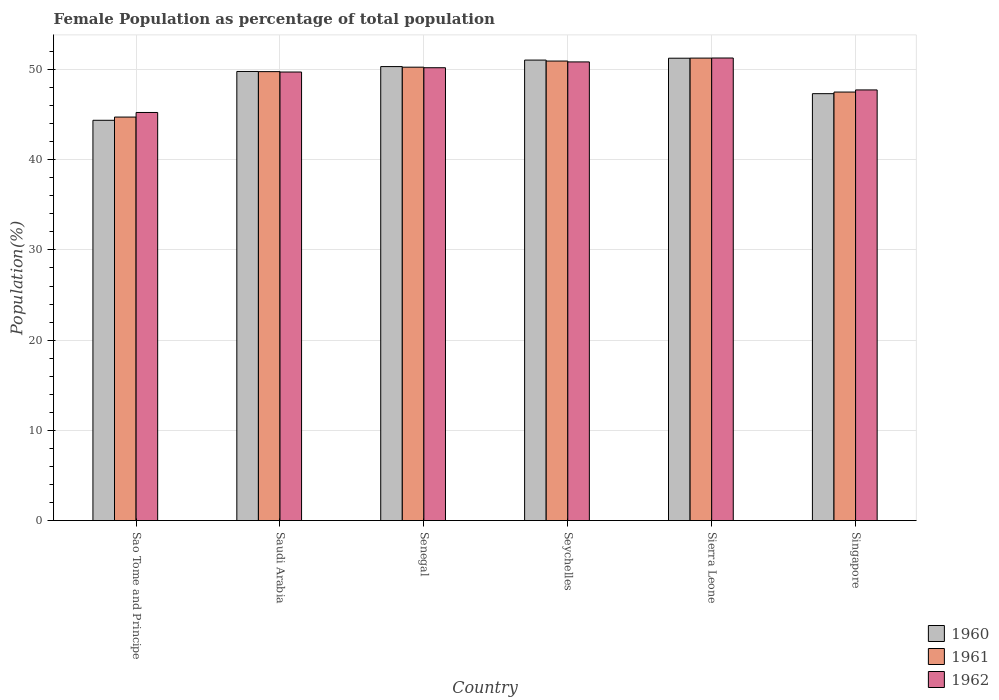How many bars are there on the 5th tick from the left?
Your answer should be compact. 3. What is the label of the 3rd group of bars from the left?
Give a very brief answer. Senegal. In how many cases, is the number of bars for a given country not equal to the number of legend labels?
Ensure brevity in your answer.  0. What is the female population in in 1960 in Saudi Arabia?
Ensure brevity in your answer.  49.78. Across all countries, what is the maximum female population in in 1962?
Provide a short and direct response. 51.27. Across all countries, what is the minimum female population in in 1960?
Your response must be concise. 44.37. In which country was the female population in in 1961 maximum?
Give a very brief answer. Sierra Leone. In which country was the female population in in 1961 minimum?
Your answer should be compact. Sao Tome and Principe. What is the total female population in in 1960 in the graph?
Your response must be concise. 294.09. What is the difference between the female population in in 1960 in Senegal and that in Sierra Leone?
Offer a very short reply. -0.93. What is the difference between the female population in in 1962 in Sao Tome and Principe and the female population in in 1960 in Seychelles?
Keep it short and to the point. -5.81. What is the average female population in in 1962 per country?
Provide a succinct answer. 49.17. What is the difference between the female population in of/in 1960 and female population in of/in 1962 in Sao Tome and Principe?
Your answer should be compact. -0.87. In how many countries, is the female population in in 1962 greater than 20 %?
Ensure brevity in your answer.  6. What is the ratio of the female population in in 1961 in Sao Tome and Principe to that in Sierra Leone?
Your answer should be compact. 0.87. Is the difference between the female population in in 1960 in Sao Tome and Principe and Sierra Leone greater than the difference between the female population in in 1962 in Sao Tome and Principe and Sierra Leone?
Ensure brevity in your answer.  No. What is the difference between the highest and the second highest female population in in 1962?
Your answer should be compact. -0.43. What is the difference between the highest and the lowest female population in in 1961?
Your answer should be compact. 6.54. What does the 3rd bar from the right in Senegal represents?
Offer a terse response. 1960. Is it the case that in every country, the sum of the female population in in 1961 and female population in in 1960 is greater than the female population in in 1962?
Provide a short and direct response. Yes. Are all the bars in the graph horizontal?
Ensure brevity in your answer.  No. Does the graph contain any zero values?
Give a very brief answer. No. Does the graph contain grids?
Ensure brevity in your answer.  Yes. How many legend labels are there?
Give a very brief answer. 3. How are the legend labels stacked?
Offer a very short reply. Vertical. What is the title of the graph?
Provide a succinct answer. Female Population as percentage of total population. What is the label or title of the Y-axis?
Ensure brevity in your answer.  Population(%). What is the Population(%) of 1960 in Sao Tome and Principe?
Make the answer very short. 44.37. What is the Population(%) in 1961 in Sao Tome and Principe?
Your response must be concise. 44.73. What is the Population(%) of 1962 in Sao Tome and Principe?
Your answer should be very brief. 45.24. What is the Population(%) of 1960 in Saudi Arabia?
Ensure brevity in your answer.  49.78. What is the Population(%) in 1961 in Saudi Arabia?
Provide a short and direct response. 49.76. What is the Population(%) of 1962 in Saudi Arabia?
Your answer should be very brief. 49.72. What is the Population(%) of 1960 in Senegal?
Ensure brevity in your answer.  50.32. What is the Population(%) of 1961 in Senegal?
Make the answer very short. 50.26. What is the Population(%) of 1962 in Senegal?
Your answer should be compact. 50.2. What is the Population(%) in 1960 in Seychelles?
Offer a terse response. 51.04. What is the Population(%) in 1961 in Seychelles?
Keep it short and to the point. 50.94. What is the Population(%) of 1962 in Seychelles?
Offer a terse response. 50.84. What is the Population(%) of 1960 in Sierra Leone?
Give a very brief answer. 51.25. What is the Population(%) of 1961 in Sierra Leone?
Provide a succinct answer. 51.26. What is the Population(%) in 1962 in Sierra Leone?
Make the answer very short. 51.27. What is the Population(%) in 1960 in Singapore?
Offer a very short reply. 47.32. What is the Population(%) in 1961 in Singapore?
Ensure brevity in your answer.  47.5. What is the Population(%) of 1962 in Singapore?
Provide a succinct answer. 47.74. Across all countries, what is the maximum Population(%) of 1960?
Provide a succinct answer. 51.25. Across all countries, what is the maximum Population(%) of 1961?
Provide a short and direct response. 51.26. Across all countries, what is the maximum Population(%) of 1962?
Offer a terse response. 51.27. Across all countries, what is the minimum Population(%) of 1960?
Provide a succinct answer. 44.37. Across all countries, what is the minimum Population(%) of 1961?
Keep it short and to the point. 44.73. Across all countries, what is the minimum Population(%) in 1962?
Keep it short and to the point. 45.24. What is the total Population(%) of 1960 in the graph?
Offer a very short reply. 294.09. What is the total Population(%) of 1961 in the graph?
Keep it short and to the point. 294.44. What is the total Population(%) of 1962 in the graph?
Make the answer very short. 295. What is the difference between the Population(%) of 1960 in Sao Tome and Principe and that in Saudi Arabia?
Provide a succinct answer. -5.41. What is the difference between the Population(%) in 1961 in Sao Tome and Principe and that in Saudi Arabia?
Your answer should be very brief. -5.04. What is the difference between the Population(%) in 1962 in Sao Tome and Principe and that in Saudi Arabia?
Your answer should be very brief. -4.48. What is the difference between the Population(%) of 1960 in Sao Tome and Principe and that in Senegal?
Ensure brevity in your answer.  -5.95. What is the difference between the Population(%) in 1961 in Sao Tome and Principe and that in Senegal?
Give a very brief answer. -5.53. What is the difference between the Population(%) in 1962 in Sao Tome and Principe and that in Senegal?
Provide a succinct answer. -4.96. What is the difference between the Population(%) of 1960 in Sao Tome and Principe and that in Seychelles?
Provide a short and direct response. -6.67. What is the difference between the Population(%) in 1961 in Sao Tome and Principe and that in Seychelles?
Ensure brevity in your answer.  -6.21. What is the difference between the Population(%) of 1962 in Sao Tome and Principe and that in Seychelles?
Make the answer very short. -5.6. What is the difference between the Population(%) in 1960 in Sao Tome and Principe and that in Sierra Leone?
Your answer should be compact. -6.88. What is the difference between the Population(%) of 1961 in Sao Tome and Principe and that in Sierra Leone?
Ensure brevity in your answer.  -6.54. What is the difference between the Population(%) in 1962 in Sao Tome and Principe and that in Sierra Leone?
Your answer should be very brief. -6.04. What is the difference between the Population(%) of 1960 in Sao Tome and Principe and that in Singapore?
Offer a terse response. -2.95. What is the difference between the Population(%) in 1961 in Sao Tome and Principe and that in Singapore?
Keep it short and to the point. -2.77. What is the difference between the Population(%) of 1962 in Sao Tome and Principe and that in Singapore?
Your response must be concise. -2.5. What is the difference between the Population(%) of 1960 in Saudi Arabia and that in Senegal?
Ensure brevity in your answer.  -0.54. What is the difference between the Population(%) in 1961 in Saudi Arabia and that in Senegal?
Provide a succinct answer. -0.49. What is the difference between the Population(%) of 1962 in Saudi Arabia and that in Senegal?
Offer a very short reply. -0.48. What is the difference between the Population(%) in 1960 in Saudi Arabia and that in Seychelles?
Provide a short and direct response. -1.26. What is the difference between the Population(%) in 1961 in Saudi Arabia and that in Seychelles?
Offer a terse response. -1.17. What is the difference between the Population(%) of 1962 in Saudi Arabia and that in Seychelles?
Give a very brief answer. -1.12. What is the difference between the Population(%) in 1960 in Saudi Arabia and that in Sierra Leone?
Offer a very short reply. -1.47. What is the difference between the Population(%) in 1961 in Saudi Arabia and that in Sierra Leone?
Provide a short and direct response. -1.5. What is the difference between the Population(%) in 1962 in Saudi Arabia and that in Sierra Leone?
Your response must be concise. -1.55. What is the difference between the Population(%) of 1960 in Saudi Arabia and that in Singapore?
Your response must be concise. 2.46. What is the difference between the Population(%) of 1961 in Saudi Arabia and that in Singapore?
Ensure brevity in your answer.  2.26. What is the difference between the Population(%) of 1962 in Saudi Arabia and that in Singapore?
Give a very brief answer. 1.98. What is the difference between the Population(%) of 1960 in Senegal and that in Seychelles?
Offer a terse response. -0.72. What is the difference between the Population(%) in 1961 in Senegal and that in Seychelles?
Keep it short and to the point. -0.68. What is the difference between the Population(%) of 1962 in Senegal and that in Seychelles?
Provide a short and direct response. -0.64. What is the difference between the Population(%) in 1960 in Senegal and that in Sierra Leone?
Keep it short and to the point. -0.93. What is the difference between the Population(%) in 1961 in Senegal and that in Sierra Leone?
Provide a succinct answer. -1.01. What is the difference between the Population(%) of 1962 in Senegal and that in Sierra Leone?
Offer a very short reply. -1.08. What is the difference between the Population(%) in 1960 in Senegal and that in Singapore?
Give a very brief answer. 3. What is the difference between the Population(%) of 1961 in Senegal and that in Singapore?
Offer a terse response. 2.76. What is the difference between the Population(%) of 1962 in Senegal and that in Singapore?
Keep it short and to the point. 2.46. What is the difference between the Population(%) of 1960 in Seychelles and that in Sierra Leone?
Your answer should be compact. -0.21. What is the difference between the Population(%) of 1961 in Seychelles and that in Sierra Leone?
Keep it short and to the point. -0.33. What is the difference between the Population(%) in 1962 in Seychelles and that in Sierra Leone?
Offer a very short reply. -0.43. What is the difference between the Population(%) in 1960 in Seychelles and that in Singapore?
Offer a very short reply. 3.72. What is the difference between the Population(%) of 1961 in Seychelles and that in Singapore?
Offer a very short reply. 3.44. What is the difference between the Population(%) of 1962 in Seychelles and that in Singapore?
Make the answer very short. 3.1. What is the difference between the Population(%) of 1960 in Sierra Leone and that in Singapore?
Give a very brief answer. 3.93. What is the difference between the Population(%) of 1961 in Sierra Leone and that in Singapore?
Your answer should be compact. 3.76. What is the difference between the Population(%) in 1962 in Sierra Leone and that in Singapore?
Your answer should be very brief. 3.54. What is the difference between the Population(%) in 1960 in Sao Tome and Principe and the Population(%) in 1961 in Saudi Arabia?
Give a very brief answer. -5.39. What is the difference between the Population(%) in 1960 in Sao Tome and Principe and the Population(%) in 1962 in Saudi Arabia?
Ensure brevity in your answer.  -5.35. What is the difference between the Population(%) of 1961 in Sao Tome and Principe and the Population(%) of 1962 in Saudi Arabia?
Offer a terse response. -4.99. What is the difference between the Population(%) of 1960 in Sao Tome and Principe and the Population(%) of 1961 in Senegal?
Your response must be concise. -5.89. What is the difference between the Population(%) of 1960 in Sao Tome and Principe and the Population(%) of 1962 in Senegal?
Your answer should be compact. -5.83. What is the difference between the Population(%) in 1961 in Sao Tome and Principe and the Population(%) in 1962 in Senegal?
Your response must be concise. -5.47. What is the difference between the Population(%) in 1960 in Sao Tome and Principe and the Population(%) in 1961 in Seychelles?
Make the answer very short. -6.57. What is the difference between the Population(%) of 1960 in Sao Tome and Principe and the Population(%) of 1962 in Seychelles?
Your answer should be compact. -6.47. What is the difference between the Population(%) of 1961 in Sao Tome and Principe and the Population(%) of 1962 in Seychelles?
Provide a succinct answer. -6.11. What is the difference between the Population(%) of 1960 in Sao Tome and Principe and the Population(%) of 1961 in Sierra Leone?
Provide a succinct answer. -6.89. What is the difference between the Population(%) of 1960 in Sao Tome and Principe and the Population(%) of 1962 in Sierra Leone?
Offer a very short reply. -6.9. What is the difference between the Population(%) in 1961 in Sao Tome and Principe and the Population(%) in 1962 in Sierra Leone?
Give a very brief answer. -6.55. What is the difference between the Population(%) of 1960 in Sao Tome and Principe and the Population(%) of 1961 in Singapore?
Provide a succinct answer. -3.13. What is the difference between the Population(%) of 1960 in Sao Tome and Principe and the Population(%) of 1962 in Singapore?
Ensure brevity in your answer.  -3.37. What is the difference between the Population(%) of 1961 in Sao Tome and Principe and the Population(%) of 1962 in Singapore?
Provide a short and direct response. -3.01. What is the difference between the Population(%) in 1960 in Saudi Arabia and the Population(%) in 1961 in Senegal?
Ensure brevity in your answer.  -0.47. What is the difference between the Population(%) of 1960 in Saudi Arabia and the Population(%) of 1962 in Senegal?
Your answer should be very brief. -0.41. What is the difference between the Population(%) of 1961 in Saudi Arabia and the Population(%) of 1962 in Senegal?
Ensure brevity in your answer.  -0.43. What is the difference between the Population(%) of 1960 in Saudi Arabia and the Population(%) of 1961 in Seychelles?
Offer a very short reply. -1.15. What is the difference between the Population(%) of 1960 in Saudi Arabia and the Population(%) of 1962 in Seychelles?
Make the answer very short. -1.06. What is the difference between the Population(%) in 1961 in Saudi Arabia and the Population(%) in 1962 in Seychelles?
Your answer should be compact. -1.08. What is the difference between the Population(%) of 1960 in Saudi Arabia and the Population(%) of 1961 in Sierra Leone?
Your answer should be very brief. -1.48. What is the difference between the Population(%) of 1960 in Saudi Arabia and the Population(%) of 1962 in Sierra Leone?
Provide a short and direct response. -1.49. What is the difference between the Population(%) of 1961 in Saudi Arabia and the Population(%) of 1962 in Sierra Leone?
Your answer should be compact. -1.51. What is the difference between the Population(%) in 1960 in Saudi Arabia and the Population(%) in 1961 in Singapore?
Your response must be concise. 2.28. What is the difference between the Population(%) in 1960 in Saudi Arabia and the Population(%) in 1962 in Singapore?
Provide a short and direct response. 2.05. What is the difference between the Population(%) in 1961 in Saudi Arabia and the Population(%) in 1962 in Singapore?
Your answer should be very brief. 2.03. What is the difference between the Population(%) of 1960 in Senegal and the Population(%) of 1961 in Seychelles?
Your answer should be very brief. -0.61. What is the difference between the Population(%) in 1960 in Senegal and the Population(%) in 1962 in Seychelles?
Your answer should be very brief. -0.52. What is the difference between the Population(%) of 1961 in Senegal and the Population(%) of 1962 in Seychelles?
Offer a very short reply. -0.58. What is the difference between the Population(%) of 1960 in Senegal and the Population(%) of 1961 in Sierra Leone?
Your response must be concise. -0.94. What is the difference between the Population(%) of 1960 in Senegal and the Population(%) of 1962 in Sierra Leone?
Offer a terse response. -0.95. What is the difference between the Population(%) of 1961 in Senegal and the Population(%) of 1962 in Sierra Leone?
Provide a succinct answer. -1.02. What is the difference between the Population(%) in 1960 in Senegal and the Population(%) in 1961 in Singapore?
Offer a very short reply. 2.82. What is the difference between the Population(%) of 1960 in Senegal and the Population(%) of 1962 in Singapore?
Give a very brief answer. 2.59. What is the difference between the Population(%) of 1961 in Senegal and the Population(%) of 1962 in Singapore?
Provide a succinct answer. 2.52. What is the difference between the Population(%) in 1960 in Seychelles and the Population(%) in 1961 in Sierra Leone?
Your answer should be compact. -0.22. What is the difference between the Population(%) of 1960 in Seychelles and the Population(%) of 1962 in Sierra Leone?
Give a very brief answer. -0.23. What is the difference between the Population(%) of 1961 in Seychelles and the Population(%) of 1962 in Sierra Leone?
Ensure brevity in your answer.  -0.34. What is the difference between the Population(%) of 1960 in Seychelles and the Population(%) of 1961 in Singapore?
Your answer should be compact. 3.54. What is the difference between the Population(%) in 1960 in Seychelles and the Population(%) in 1962 in Singapore?
Your response must be concise. 3.31. What is the difference between the Population(%) in 1961 in Seychelles and the Population(%) in 1962 in Singapore?
Your response must be concise. 3.2. What is the difference between the Population(%) in 1960 in Sierra Leone and the Population(%) in 1961 in Singapore?
Offer a very short reply. 3.75. What is the difference between the Population(%) in 1960 in Sierra Leone and the Population(%) in 1962 in Singapore?
Keep it short and to the point. 3.52. What is the difference between the Population(%) of 1961 in Sierra Leone and the Population(%) of 1962 in Singapore?
Keep it short and to the point. 3.53. What is the average Population(%) in 1960 per country?
Make the answer very short. 49.01. What is the average Population(%) in 1961 per country?
Your answer should be compact. 49.07. What is the average Population(%) of 1962 per country?
Your response must be concise. 49.17. What is the difference between the Population(%) in 1960 and Population(%) in 1961 in Sao Tome and Principe?
Your answer should be very brief. -0.36. What is the difference between the Population(%) of 1960 and Population(%) of 1962 in Sao Tome and Principe?
Your answer should be compact. -0.87. What is the difference between the Population(%) in 1961 and Population(%) in 1962 in Sao Tome and Principe?
Make the answer very short. -0.51. What is the difference between the Population(%) in 1960 and Population(%) in 1961 in Saudi Arabia?
Offer a very short reply. 0.02. What is the difference between the Population(%) in 1960 and Population(%) in 1962 in Saudi Arabia?
Your answer should be very brief. 0.06. What is the difference between the Population(%) in 1961 and Population(%) in 1962 in Saudi Arabia?
Provide a short and direct response. 0.04. What is the difference between the Population(%) of 1960 and Population(%) of 1961 in Senegal?
Your answer should be very brief. 0.07. What is the difference between the Population(%) in 1960 and Population(%) in 1962 in Senegal?
Provide a short and direct response. 0.13. What is the difference between the Population(%) of 1961 and Population(%) of 1962 in Senegal?
Provide a short and direct response. 0.06. What is the difference between the Population(%) of 1960 and Population(%) of 1961 in Seychelles?
Give a very brief answer. 0.11. What is the difference between the Population(%) of 1960 and Population(%) of 1962 in Seychelles?
Your response must be concise. 0.2. What is the difference between the Population(%) in 1961 and Population(%) in 1962 in Seychelles?
Offer a terse response. 0.1. What is the difference between the Population(%) in 1960 and Population(%) in 1961 in Sierra Leone?
Your answer should be very brief. -0.01. What is the difference between the Population(%) of 1960 and Population(%) of 1962 in Sierra Leone?
Your answer should be compact. -0.02. What is the difference between the Population(%) in 1961 and Population(%) in 1962 in Sierra Leone?
Offer a very short reply. -0.01. What is the difference between the Population(%) in 1960 and Population(%) in 1961 in Singapore?
Your response must be concise. -0.18. What is the difference between the Population(%) in 1960 and Population(%) in 1962 in Singapore?
Give a very brief answer. -0.41. What is the difference between the Population(%) of 1961 and Population(%) of 1962 in Singapore?
Offer a very short reply. -0.24. What is the ratio of the Population(%) in 1960 in Sao Tome and Principe to that in Saudi Arabia?
Make the answer very short. 0.89. What is the ratio of the Population(%) in 1961 in Sao Tome and Principe to that in Saudi Arabia?
Your answer should be compact. 0.9. What is the ratio of the Population(%) in 1962 in Sao Tome and Principe to that in Saudi Arabia?
Keep it short and to the point. 0.91. What is the ratio of the Population(%) in 1960 in Sao Tome and Principe to that in Senegal?
Give a very brief answer. 0.88. What is the ratio of the Population(%) in 1961 in Sao Tome and Principe to that in Senegal?
Offer a terse response. 0.89. What is the ratio of the Population(%) in 1962 in Sao Tome and Principe to that in Senegal?
Your response must be concise. 0.9. What is the ratio of the Population(%) of 1960 in Sao Tome and Principe to that in Seychelles?
Offer a terse response. 0.87. What is the ratio of the Population(%) of 1961 in Sao Tome and Principe to that in Seychelles?
Your answer should be compact. 0.88. What is the ratio of the Population(%) of 1962 in Sao Tome and Principe to that in Seychelles?
Offer a very short reply. 0.89. What is the ratio of the Population(%) in 1960 in Sao Tome and Principe to that in Sierra Leone?
Make the answer very short. 0.87. What is the ratio of the Population(%) in 1961 in Sao Tome and Principe to that in Sierra Leone?
Your answer should be compact. 0.87. What is the ratio of the Population(%) in 1962 in Sao Tome and Principe to that in Sierra Leone?
Offer a terse response. 0.88. What is the ratio of the Population(%) of 1960 in Sao Tome and Principe to that in Singapore?
Ensure brevity in your answer.  0.94. What is the ratio of the Population(%) of 1961 in Sao Tome and Principe to that in Singapore?
Offer a terse response. 0.94. What is the ratio of the Population(%) of 1962 in Sao Tome and Principe to that in Singapore?
Provide a short and direct response. 0.95. What is the ratio of the Population(%) of 1960 in Saudi Arabia to that in Senegal?
Make the answer very short. 0.99. What is the ratio of the Population(%) in 1961 in Saudi Arabia to that in Senegal?
Give a very brief answer. 0.99. What is the ratio of the Population(%) of 1960 in Saudi Arabia to that in Seychelles?
Ensure brevity in your answer.  0.98. What is the ratio of the Population(%) of 1961 in Saudi Arabia to that in Seychelles?
Keep it short and to the point. 0.98. What is the ratio of the Population(%) in 1960 in Saudi Arabia to that in Sierra Leone?
Offer a very short reply. 0.97. What is the ratio of the Population(%) in 1961 in Saudi Arabia to that in Sierra Leone?
Offer a terse response. 0.97. What is the ratio of the Population(%) in 1962 in Saudi Arabia to that in Sierra Leone?
Give a very brief answer. 0.97. What is the ratio of the Population(%) in 1960 in Saudi Arabia to that in Singapore?
Provide a short and direct response. 1.05. What is the ratio of the Population(%) in 1961 in Saudi Arabia to that in Singapore?
Make the answer very short. 1.05. What is the ratio of the Population(%) of 1962 in Saudi Arabia to that in Singapore?
Your response must be concise. 1.04. What is the ratio of the Population(%) of 1960 in Senegal to that in Seychelles?
Keep it short and to the point. 0.99. What is the ratio of the Population(%) in 1961 in Senegal to that in Seychelles?
Your answer should be very brief. 0.99. What is the ratio of the Population(%) in 1962 in Senegal to that in Seychelles?
Offer a terse response. 0.99. What is the ratio of the Population(%) of 1960 in Senegal to that in Sierra Leone?
Keep it short and to the point. 0.98. What is the ratio of the Population(%) of 1961 in Senegal to that in Sierra Leone?
Make the answer very short. 0.98. What is the ratio of the Population(%) in 1960 in Senegal to that in Singapore?
Your answer should be compact. 1.06. What is the ratio of the Population(%) of 1961 in Senegal to that in Singapore?
Ensure brevity in your answer.  1.06. What is the ratio of the Population(%) of 1962 in Senegal to that in Singapore?
Your response must be concise. 1.05. What is the ratio of the Population(%) of 1961 in Seychelles to that in Sierra Leone?
Make the answer very short. 0.99. What is the ratio of the Population(%) in 1960 in Seychelles to that in Singapore?
Give a very brief answer. 1.08. What is the ratio of the Population(%) in 1961 in Seychelles to that in Singapore?
Provide a succinct answer. 1.07. What is the ratio of the Population(%) of 1962 in Seychelles to that in Singapore?
Your response must be concise. 1.06. What is the ratio of the Population(%) in 1960 in Sierra Leone to that in Singapore?
Your answer should be compact. 1.08. What is the ratio of the Population(%) in 1961 in Sierra Leone to that in Singapore?
Your response must be concise. 1.08. What is the ratio of the Population(%) in 1962 in Sierra Leone to that in Singapore?
Provide a short and direct response. 1.07. What is the difference between the highest and the second highest Population(%) in 1960?
Provide a short and direct response. 0.21. What is the difference between the highest and the second highest Population(%) in 1961?
Ensure brevity in your answer.  0.33. What is the difference between the highest and the second highest Population(%) in 1962?
Give a very brief answer. 0.43. What is the difference between the highest and the lowest Population(%) of 1960?
Offer a terse response. 6.88. What is the difference between the highest and the lowest Population(%) in 1961?
Ensure brevity in your answer.  6.54. What is the difference between the highest and the lowest Population(%) in 1962?
Make the answer very short. 6.04. 